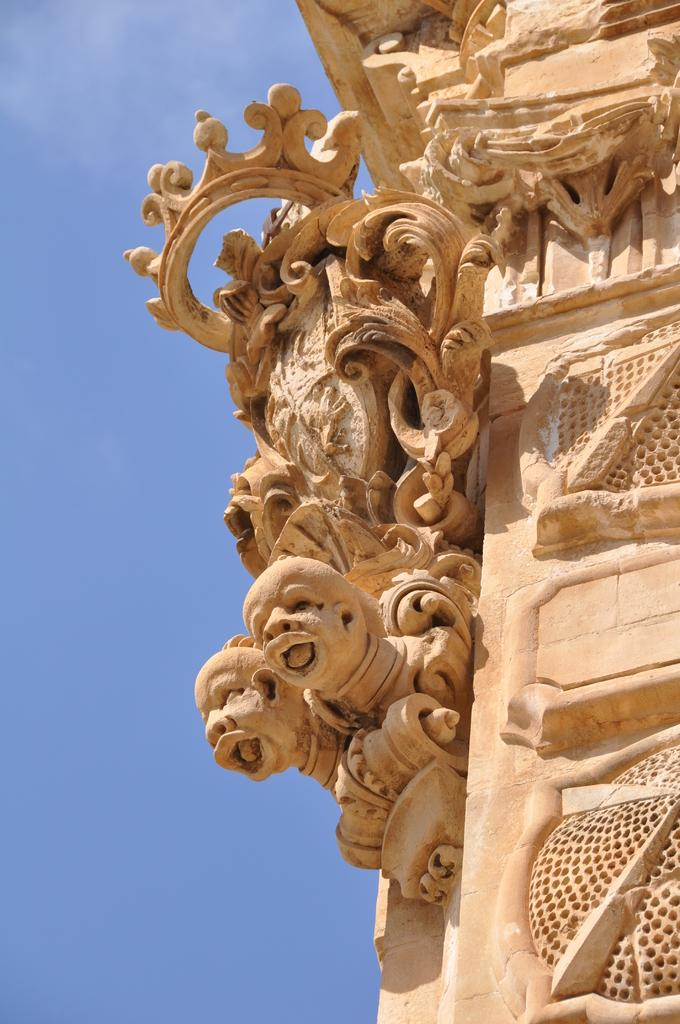What type of art is present in the image? There are sculptures in the image. What can be seen in the background of the image? The sky is visible in the background of the image. How many shoes are visible in the image? There are no shoes present in the image; it features sculptures and a sky background. What type of animal can be seen playing in the garden in the image? There is no garden or animal present in the image. 